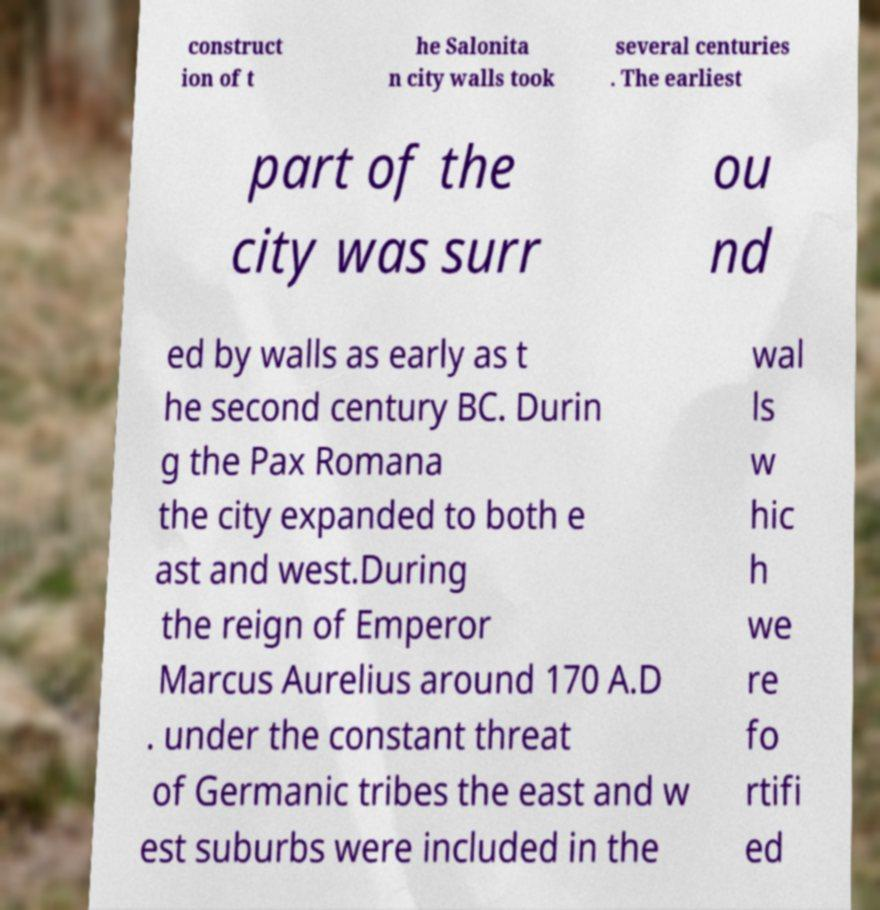Please read and relay the text visible in this image. What does it say? construct ion of t he Salonita n city walls took several centuries . The earliest part of the city was surr ou nd ed by walls as early as t he second century BC. Durin g the Pax Romana the city expanded to both e ast and west.During the reign of Emperor Marcus Aurelius around 170 A.D . under the constant threat of Germanic tribes the east and w est suburbs were included in the wal ls w hic h we re fo rtifi ed 